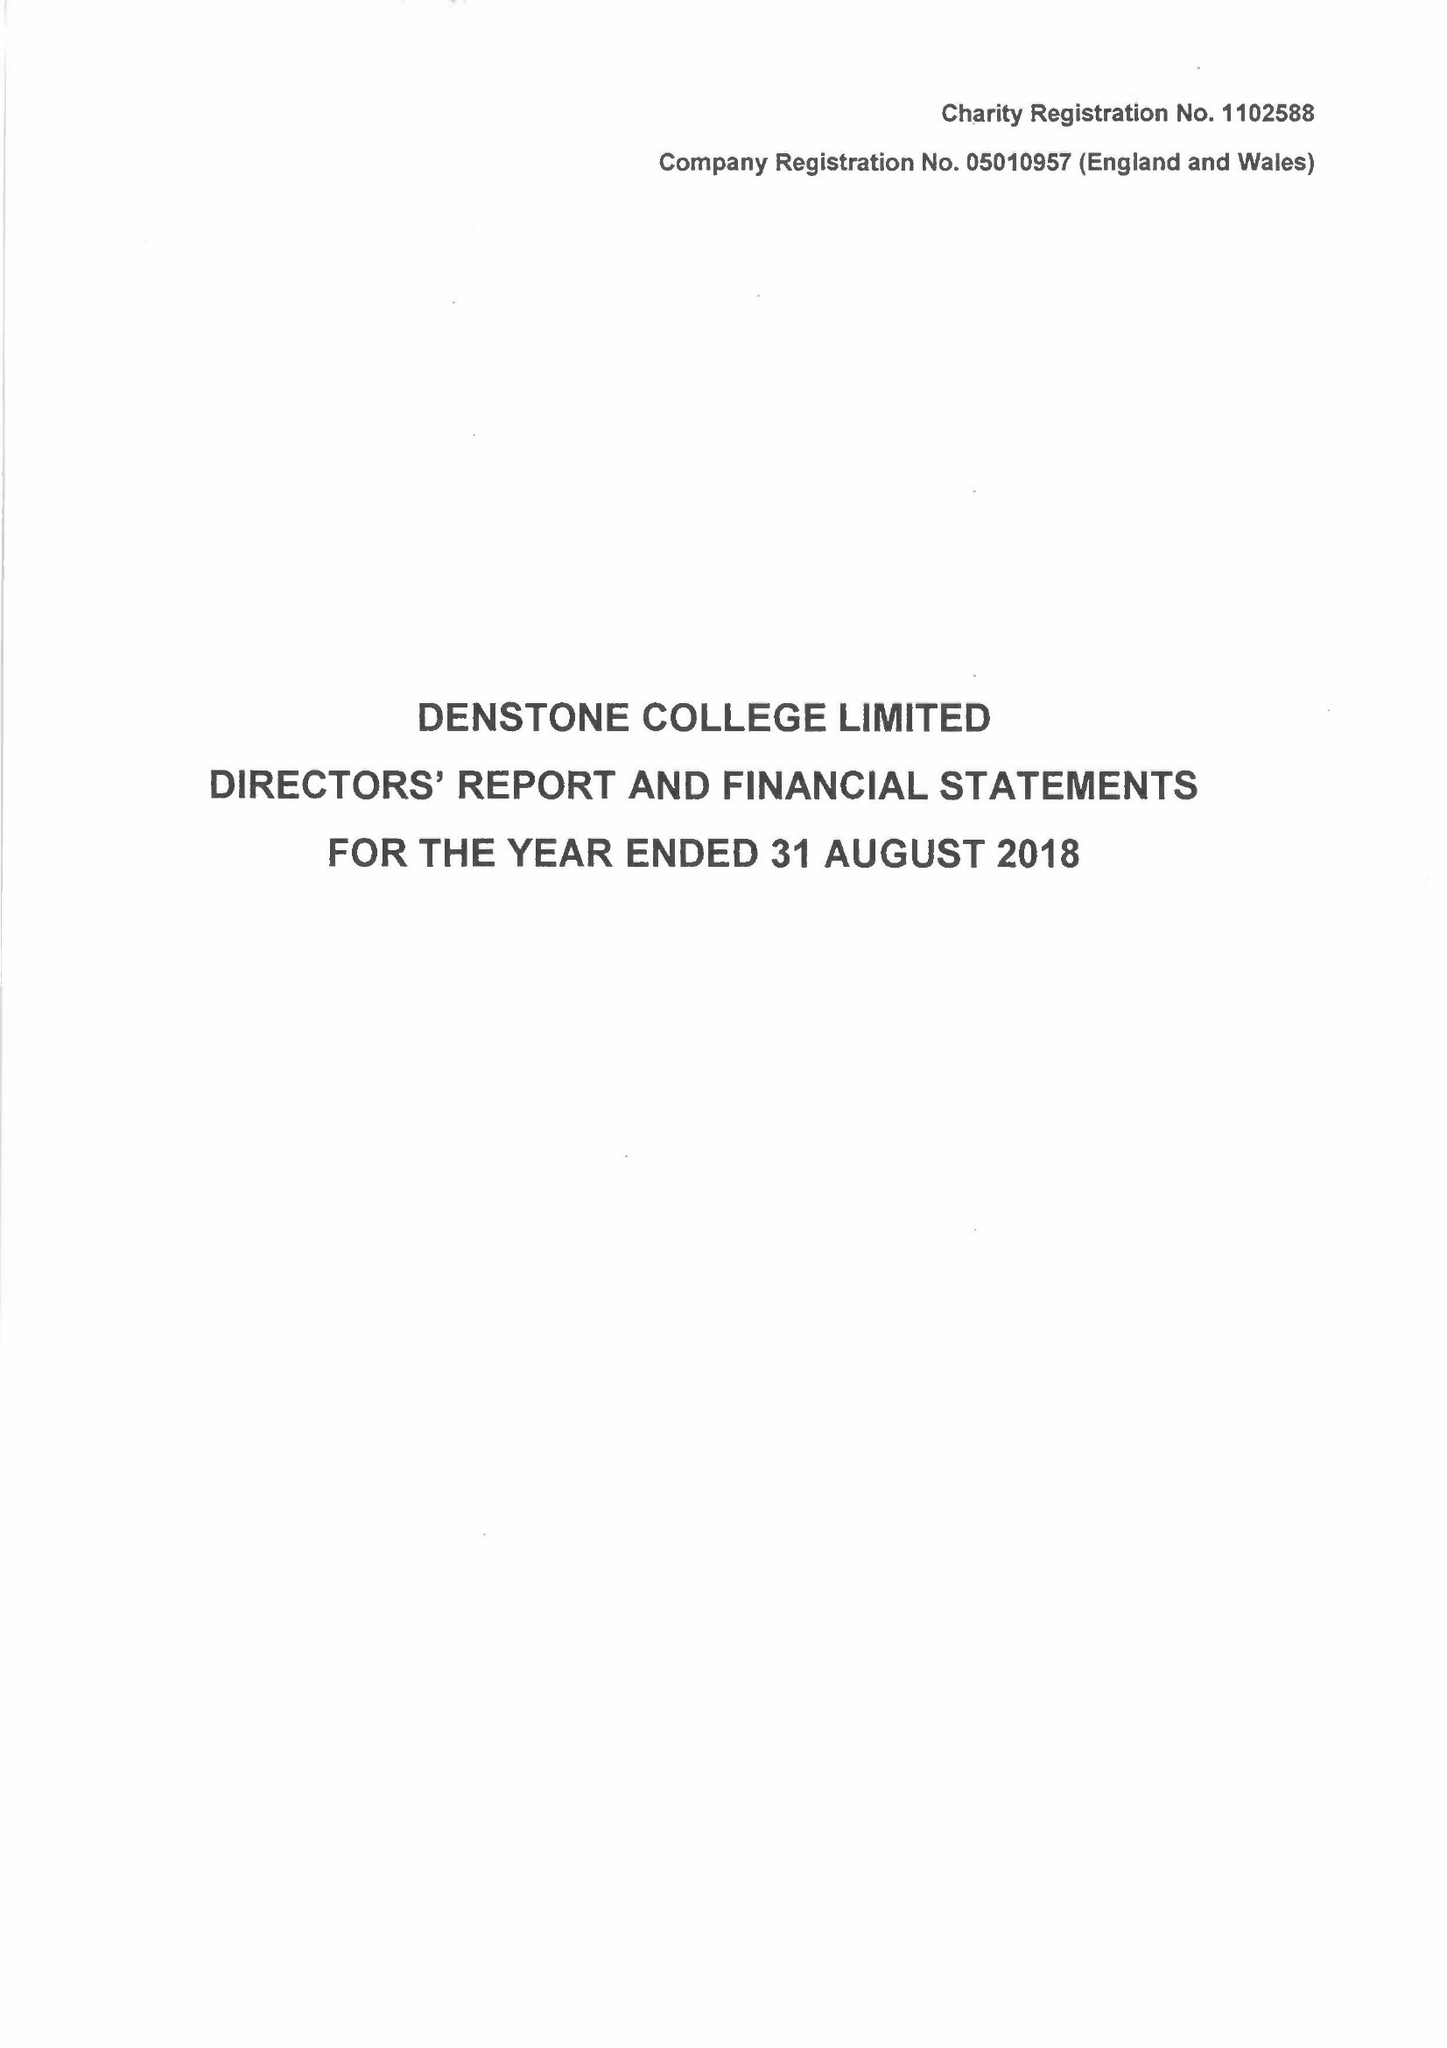What is the value for the charity_number?
Answer the question using a single word or phrase. 1102588 